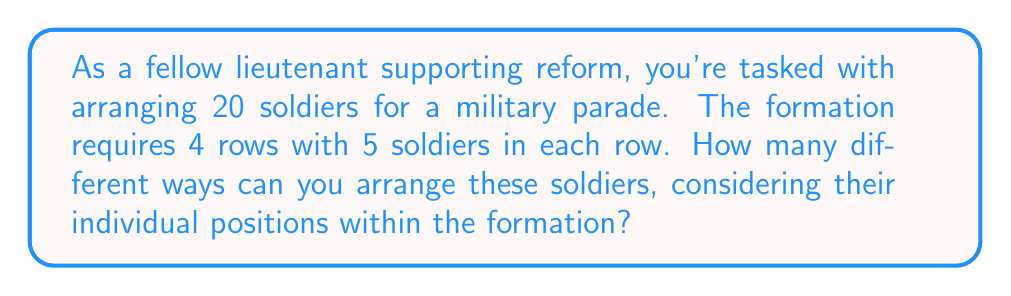Could you help me with this problem? Let's approach this step-by-step:

1) We have 20 soldiers in total, and each soldier's position is distinct.

2) This is a permutation problem because the order matters (each position in the formation is unique).

3) We're essentially arranging all 20 soldiers, so we'll use the formula for permutations of n distinct objects:

   $$P(n) = n!$$

4) In this case, n = 20, so we calculate:

   $$P(20) = 20!$$

5) Let's expand this:
   
   $$20! = 20 \times 19 \times 18 \times 17 \times ... \times 3 \times 2 \times 1$$

6) Computing this large number:

   $$20! = 2,432,902,008,176,640,000$$

This means there are 2,432,902,008,176,640,000 different ways to arrange 20 soldiers in the specified formation.
Answer: $20! = 2,432,902,008,176,640,000$ arrangements 